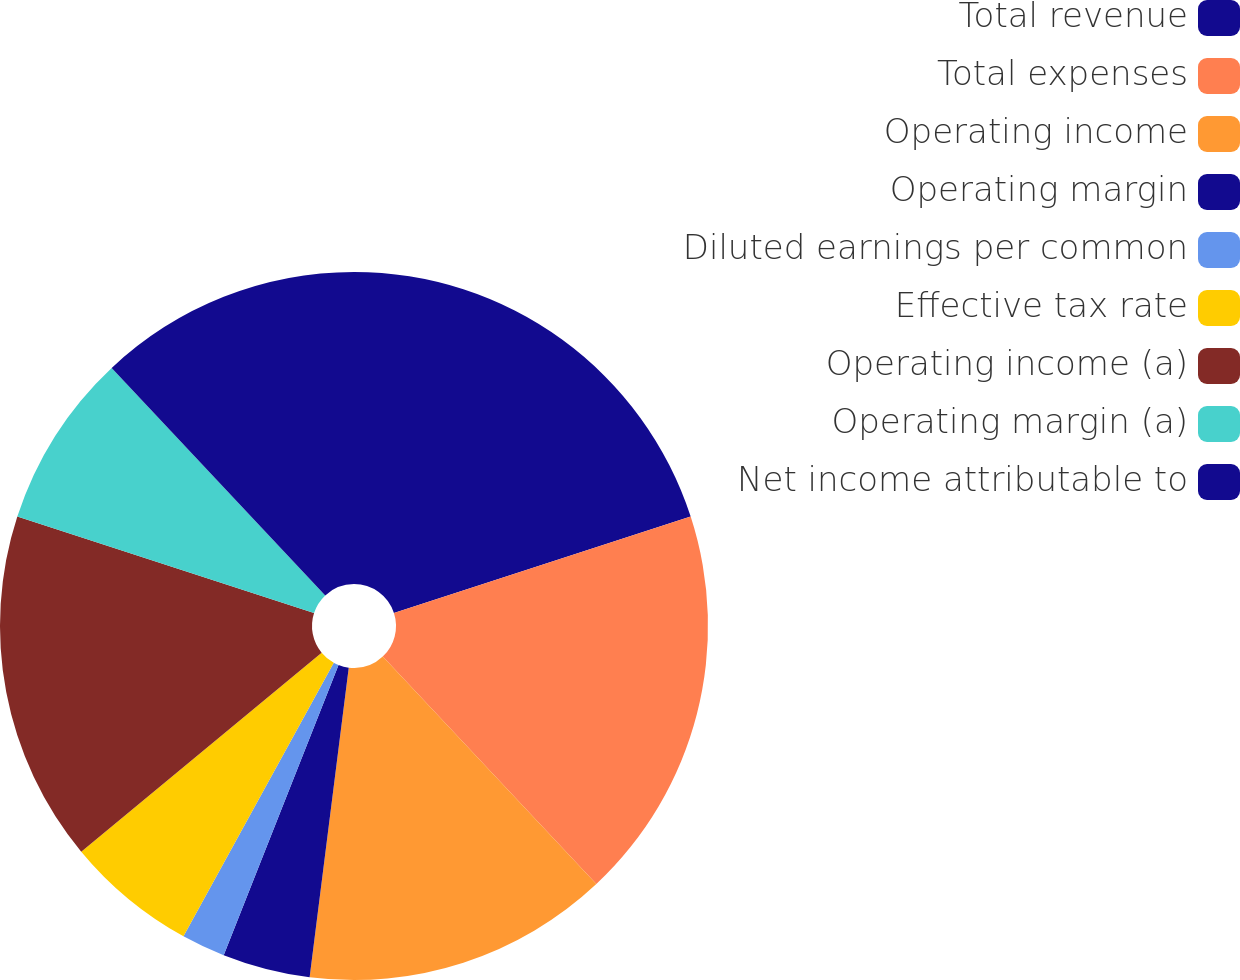Convert chart to OTSL. <chart><loc_0><loc_0><loc_500><loc_500><pie_chart><fcel>Total revenue<fcel>Total expenses<fcel>Operating income<fcel>Operating margin<fcel>Diluted earnings per common<fcel>Effective tax rate<fcel>Operating income (a)<fcel>Operating margin (a)<fcel>Net income attributable to<nl><fcel>20.0%<fcel>18.0%<fcel>14.0%<fcel>4.0%<fcel>2.0%<fcel>6.0%<fcel>16.0%<fcel>8.0%<fcel>12.0%<nl></chart> 